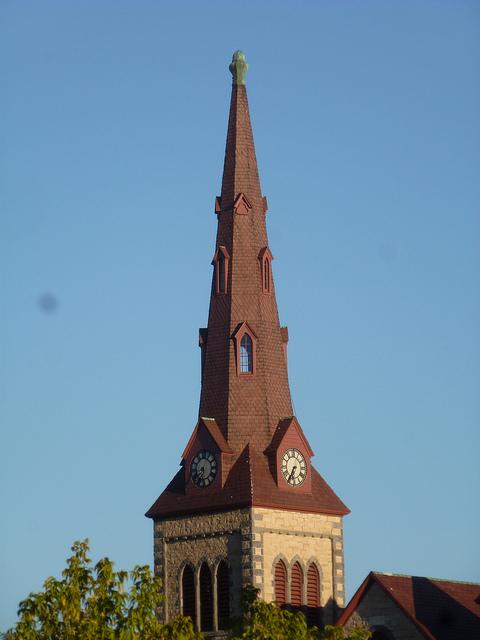What time does the clock say?
Concise answer only. 6:35. What country is this clock located in?
Write a very short answer. England. Are there any birds in the sky?
Give a very brief answer. No. Is this a tower clock?
Concise answer only. Yes. How many clock faces are there?
Keep it brief. 2. Is there a sharp point on this tower?
Keep it brief. Yes. 